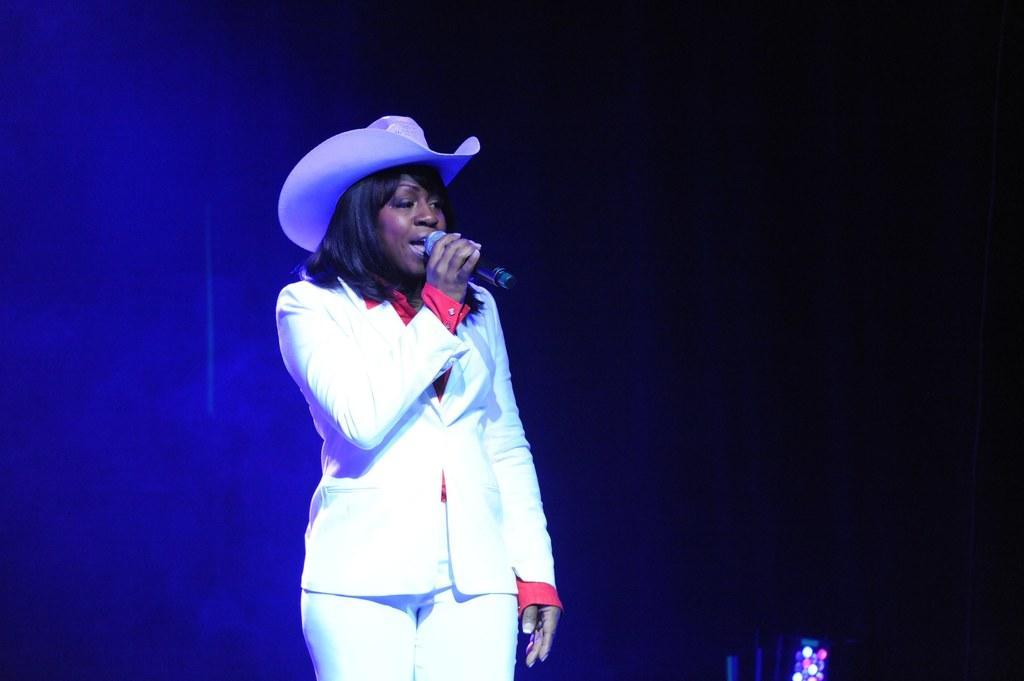How would you summarize this image in a sentence or two? In the picture I can see a person wearing white color dress and hat is holding a mic and singing. The background of the image is dark and here we can see the blue color lights on the left side of the image. 